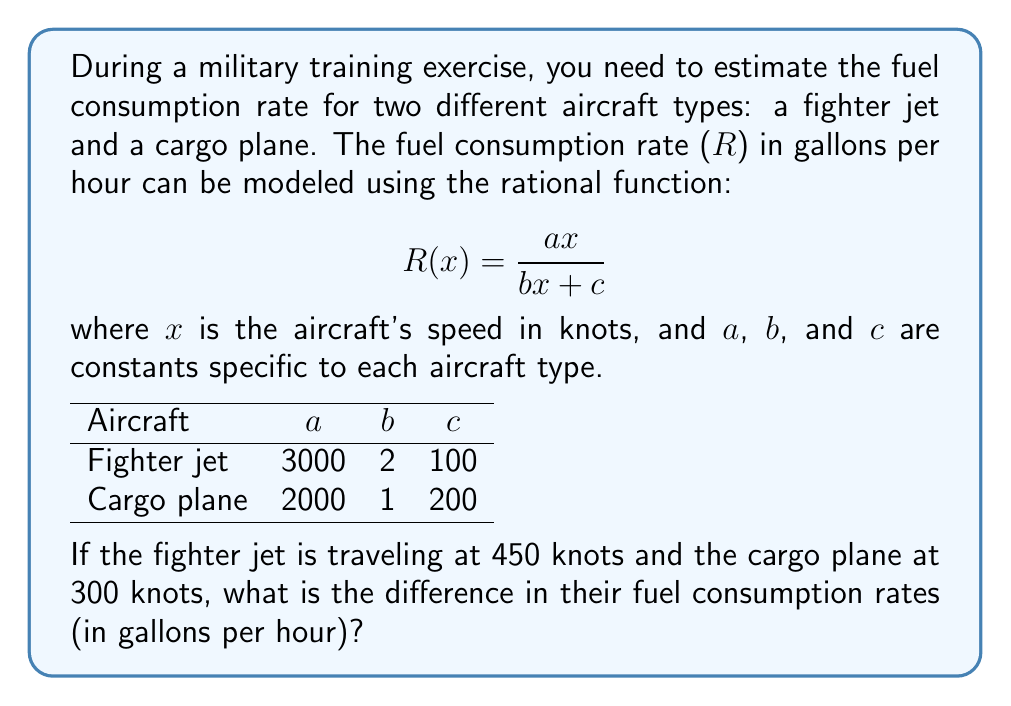Can you solve this math problem? Let's approach this step-by-step:

1) First, we'll calculate the fuel consumption rate for the fighter jet:
   $$R_{fighter}(450) = \frac{3000(450)}{2(450) + 100}$$
   $$= \frac{1,350,000}{900 + 100} = \frac{1,350,000}{1000} = 1,350$$ gallons per hour

2) Now, let's calculate the fuel consumption rate for the cargo plane:
   $$R_{cargo}(300) = \frac{2000(300)}{1(300) + 200}$$
   $$= \frac{600,000}{300 + 200} = \frac{600,000}{500} = 1,200$$ gallons per hour

3) To find the difference in fuel consumption rates, we subtract:
   $$\text{Difference} = R_{fighter}(450) - R_{cargo}(300)$$
   $$= 1,350 - 1,200 = 150$$ gallons per hour

Therefore, the fighter jet consumes 150 gallons per hour more than the cargo plane under these conditions.
Answer: 150 gallons per hour 